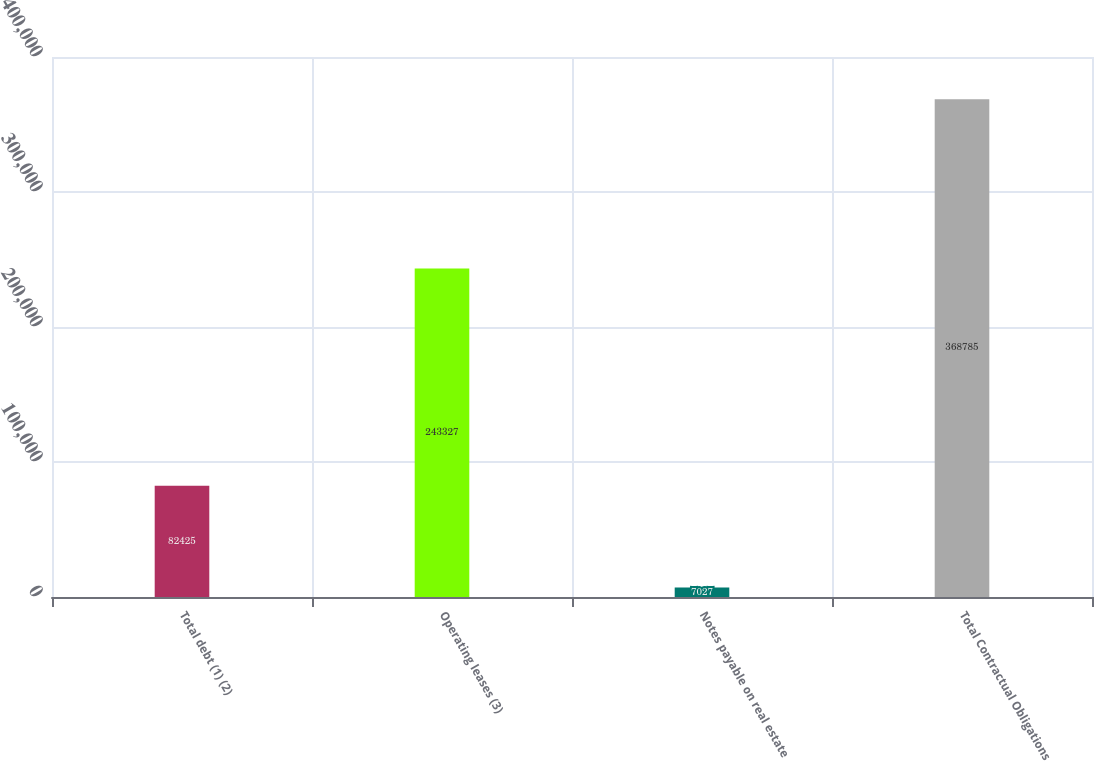<chart> <loc_0><loc_0><loc_500><loc_500><bar_chart><fcel>Total debt (1) (2)<fcel>Operating leases (3)<fcel>Notes payable on real estate<fcel>Total Contractual Obligations<nl><fcel>82425<fcel>243327<fcel>7027<fcel>368785<nl></chart> 